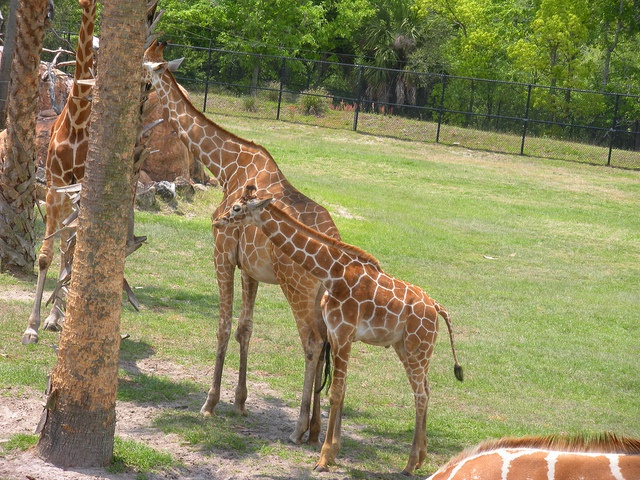Describe the objects in this image and their specific colors. I can see giraffe in black, gray, maroon, and brown tones, giraffe in black, maroon, gray, and tan tones, giraffe in black, gray, tan, and maroon tones, and giraffe in black, tan, white, and salmon tones in this image. 